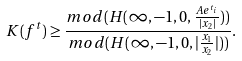Convert formula to latex. <formula><loc_0><loc_0><loc_500><loc_500>K ( f ^ { t } ) \geq \frac { m o d ( H ( \infty , - 1 , 0 , \frac { A e ^ { t _ { i } } } { | x _ { 2 } | } ) ) } { m o d ( H ( \infty , - 1 , 0 , | \frac { x _ { 1 } } { x _ { 2 } } | ) ) } .</formula> 